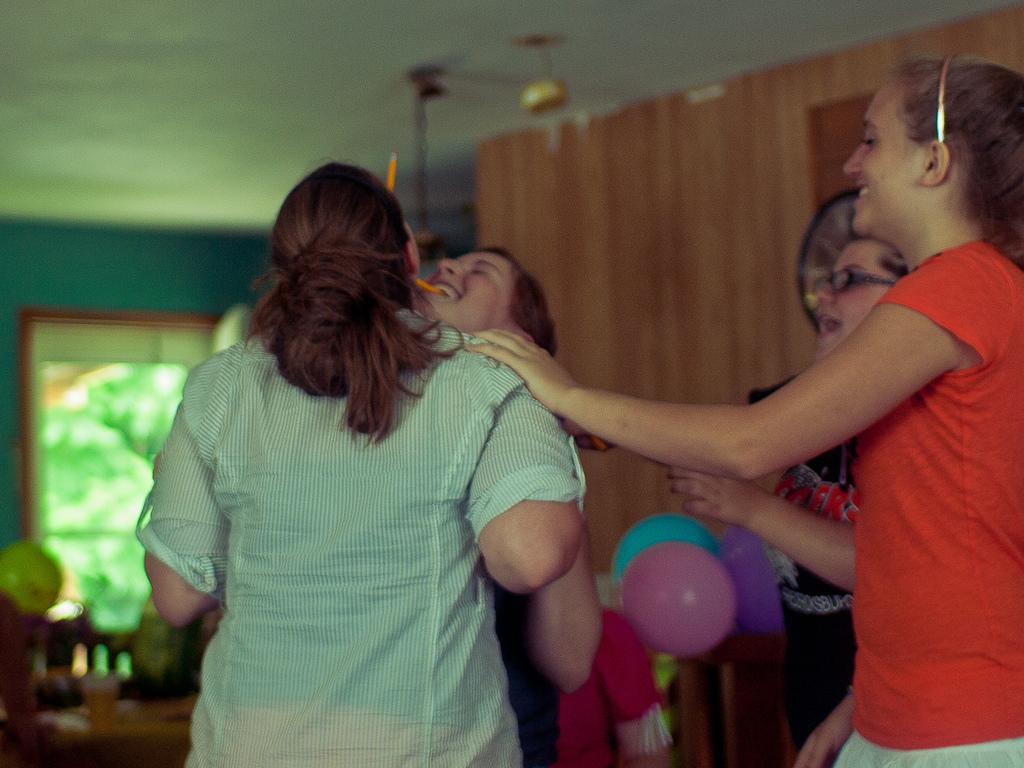In one or two sentences, can you explain what this image depicts? There is a group of people standing as we can see at the bottom of this image. We can see a wall in the background. There is a window on the left side of this image and we can see balloons at the bottom of this image. 